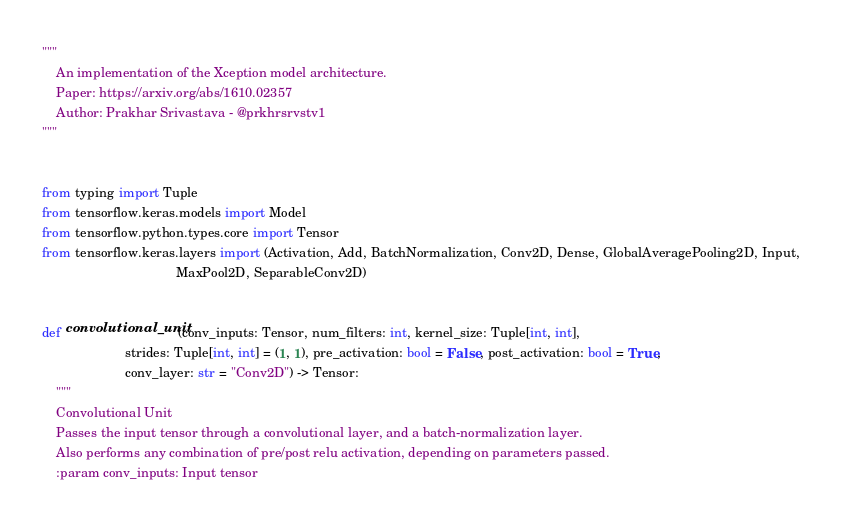Convert code to text. <code><loc_0><loc_0><loc_500><loc_500><_Python_>"""
    An implementation of the Xception model architecture.
    Paper: https://arxiv.org/abs/1610.02357
    Author: Prakhar Srivastava - @prkhrsrvstv1
"""


from typing import Tuple
from tensorflow.keras.models import Model
from tensorflow.python.types.core import Tensor
from tensorflow.keras.layers import (Activation, Add, BatchNormalization, Conv2D, Dense, GlobalAveragePooling2D, Input,
                                     MaxPool2D, SeparableConv2D)


def convolutional_unit(conv_inputs: Tensor, num_filters: int, kernel_size: Tuple[int, int],
                       strides: Tuple[int, int] = (1, 1), pre_activation: bool = False, post_activation: bool = True,
                       conv_layer: str = "Conv2D") -> Tensor:
    """
    Convolutional Unit
    Passes the input tensor through a convolutional layer, and a batch-normalization layer.
    Also performs any combination of pre/post relu activation, depending on parameters passed.
    :param conv_inputs: Input tensor</code> 